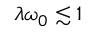<formula> <loc_0><loc_0><loc_500><loc_500>\lambda \omega _ { 0 } \lesssim 1</formula> 